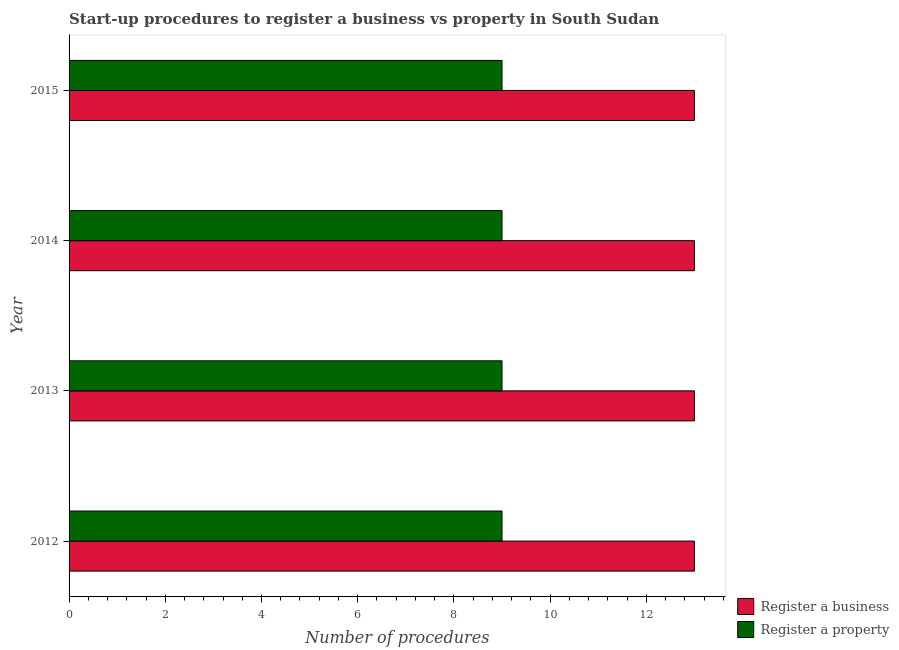Are the number of bars per tick equal to the number of legend labels?
Offer a terse response. Yes. Are the number of bars on each tick of the Y-axis equal?
Provide a short and direct response. Yes. How many bars are there on the 3rd tick from the top?
Your answer should be compact. 2. In how many cases, is the number of bars for a given year not equal to the number of legend labels?
Provide a short and direct response. 0. What is the number of procedures to register a business in 2013?
Provide a short and direct response. 13. Across all years, what is the maximum number of procedures to register a business?
Give a very brief answer. 13. Across all years, what is the minimum number of procedures to register a property?
Provide a succinct answer. 9. In which year was the number of procedures to register a business maximum?
Your answer should be compact. 2012. In which year was the number of procedures to register a business minimum?
Your answer should be compact. 2012. What is the total number of procedures to register a business in the graph?
Offer a very short reply. 52. What is the difference between the number of procedures to register a business in 2014 and that in 2015?
Offer a very short reply. 0. What is the difference between the number of procedures to register a property in 2012 and the number of procedures to register a business in 2013?
Provide a short and direct response. -4. What is the average number of procedures to register a property per year?
Keep it short and to the point. 9. In the year 2012, what is the difference between the number of procedures to register a business and number of procedures to register a property?
Your response must be concise. 4. In how many years, is the number of procedures to register a property greater than 11.6 ?
Your answer should be very brief. 0. What does the 1st bar from the top in 2012 represents?
Your answer should be compact. Register a property. What does the 2nd bar from the bottom in 2015 represents?
Your response must be concise. Register a property. What is the difference between two consecutive major ticks on the X-axis?
Offer a terse response. 2. Are the values on the major ticks of X-axis written in scientific E-notation?
Offer a terse response. No. Does the graph contain any zero values?
Your answer should be very brief. No. Does the graph contain grids?
Provide a succinct answer. No. How are the legend labels stacked?
Your answer should be very brief. Vertical. What is the title of the graph?
Provide a short and direct response. Start-up procedures to register a business vs property in South Sudan. Does "Fraud firms" appear as one of the legend labels in the graph?
Offer a terse response. No. What is the label or title of the X-axis?
Offer a very short reply. Number of procedures. What is the label or title of the Y-axis?
Give a very brief answer. Year. What is the Number of procedures in Register a business in 2013?
Offer a very short reply. 13. What is the Number of procedures in Register a property in 2013?
Give a very brief answer. 9. Across all years, what is the maximum Number of procedures of Register a business?
Provide a short and direct response. 13. Across all years, what is the maximum Number of procedures of Register a property?
Your answer should be compact. 9. Across all years, what is the minimum Number of procedures of Register a property?
Give a very brief answer. 9. What is the difference between the Number of procedures in Register a business in 2012 and that in 2013?
Give a very brief answer. 0. What is the difference between the Number of procedures of Register a business in 2012 and that in 2014?
Provide a short and direct response. 0. What is the difference between the Number of procedures of Register a business in 2012 and that in 2015?
Keep it short and to the point. 0. What is the difference between the Number of procedures of Register a property in 2012 and that in 2015?
Keep it short and to the point. 0. What is the difference between the Number of procedures in Register a business in 2013 and that in 2014?
Keep it short and to the point. 0. What is the difference between the Number of procedures of Register a property in 2013 and that in 2014?
Your answer should be compact. 0. What is the difference between the Number of procedures in Register a business in 2013 and that in 2015?
Provide a short and direct response. 0. What is the difference between the Number of procedures in Register a property in 2013 and that in 2015?
Make the answer very short. 0. What is the difference between the Number of procedures in Register a business in 2014 and that in 2015?
Make the answer very short. 0. What is the difference between the Number of procedures in Register a business in 2012 and the Number of procedures in Register a property in 2015?
Your response must be concise. 4. What is the difference between the Number of procedures of Register a business in 2013 and the Number of procedures of Register a property in 2015?
Keep it short and to the point. 4. What is the difference between the Number of procedures of Register a business in 2014 and the Number of procedures of Register a property in 2015?
Provide a succinct answer. 4. What is the average Number of procedures in Register a business per year?
Your answer should be compact. 13. What is the average Number of procedures in Register a property per year?
Ensure brevity in your answer.  9. In the year 2012, what is the difference between the Number of procedures in Register a business and Number of procedures in Register a property?
Ensure brevity in your answer.  4. In the year 2014, what is the difference between the Number of procedures of Register a business and Number of procedures of Register a property?
Offer a terse response. 4. In the year 2015, what is the difference between the Number of procedures in Register a business and Number of procedures in Register a property?
Ensure brevity in your answer.  4. What is the ratio of the Number of procedures of Register a business in 2012 to that in 2013?
Provide a succinct answer. 1. What is the ratio of the Number of procedures in Register a property in 2012 to that in 2013?
Offer a very short reply. 1. What is the ratio of the Number of procedures of Register a property in 2012 to that in 2015?
Offer a terse response. 1. What is the ratio of the Number of procedures of Register a business in 2013 to that in 2014?
Provide a short and direct response. 1. What is the ratio of the Number of procedures in Register a property in 2013 to that in 2014?
Ensure brevity in your answer.  1. What is the ratio of the Number of procedures of Register a business in 2013 to that in 2015?
Your answer should be very brief. 1. What is the ratio of the Number of procedures in Register a business in 2014 to that in 2015?
Make the answer very short. 1. What is the ratio of the Number of procedures of Register a property in 2014 to that in 2015?
Provide a short and direct response. 1. What is the difference between the highest and the second highest Number of procedures of Register a business?
Keep it short and to the point. 0. What is the difference between the highest and the second highest Number of procedures in Register a property?
Make the answer very short. 0. What is the difference between the highest and the lowest Number of procedures of Register a business?
Your response must be concise. 0. What is the difference between the highest and the lowest Number of procedures in Register a property?
Your response must be concise. 0. 